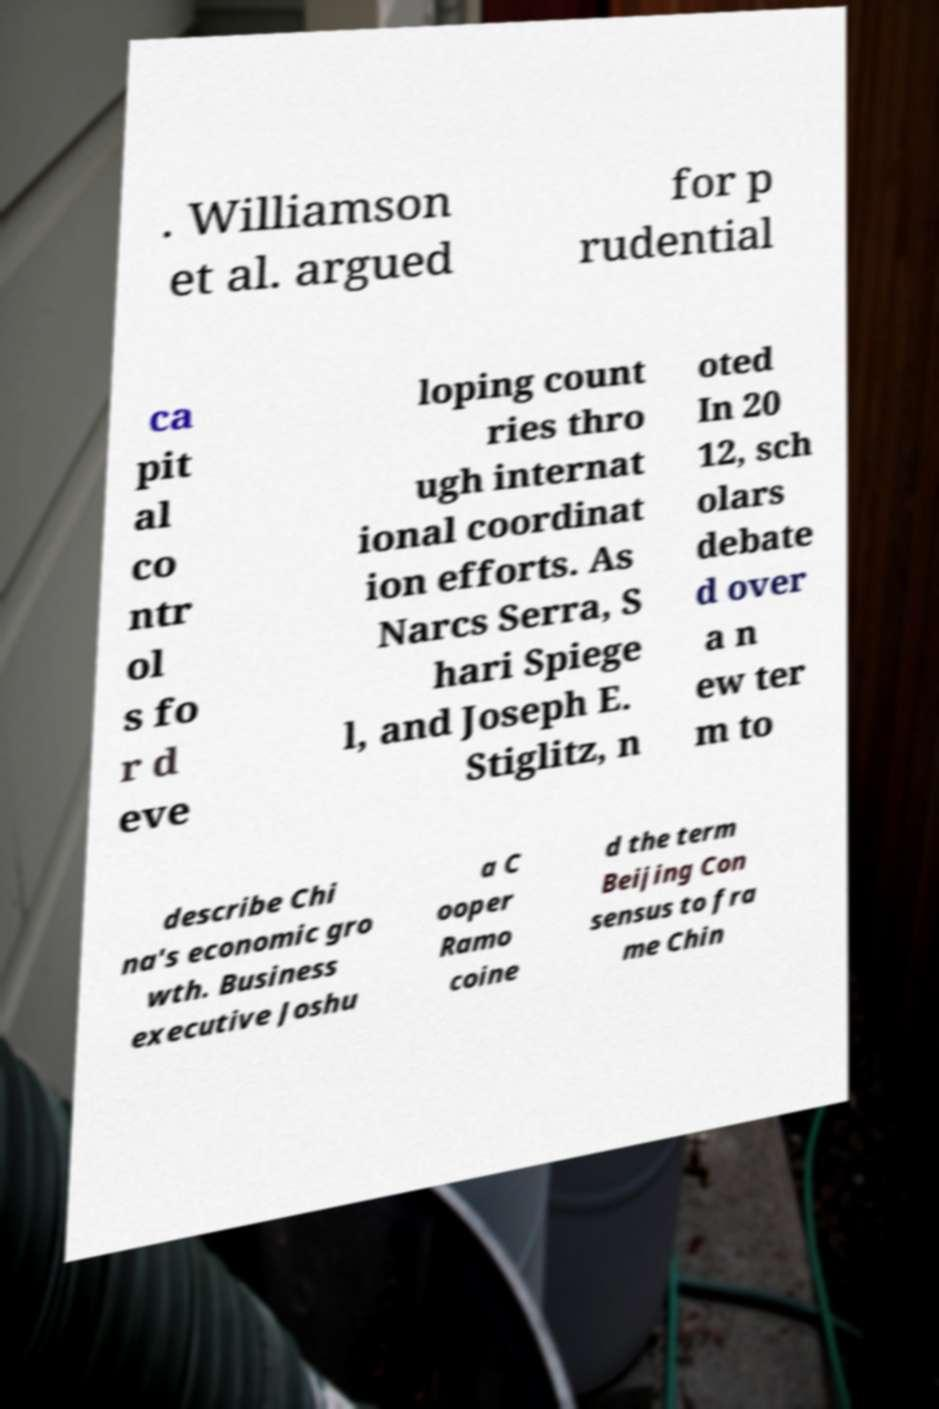Could you assist in decoding the text presented in this image and type it out clearly? . Williamson et al. argued for p rudential ca pit al co ntr ol s fo r d eve loping count ries thro ugh internat ional coordinat ion efforts. As Narcs Serra, S hari Spiege l, and Joseph E. Stiglitz, n oted In 20 12, sch olars debate d over a n ew ter m to describe Chi na's economic gro wth. Business executive Joshu a C ooper Ramo coine d the term Beijing Con sensus to fra me Chin 